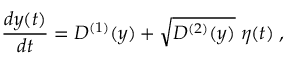Convert formula to latex. <formula><loc_0><loc_0><loc_500><loc_500>\frac { d y ( t ) } { d t } = D ^ { ( 1 ) } ( y ) + \sqrt { D ^ { ( 2 ) } ( y ) } \, \eta ( t ) \, ,</formula> 